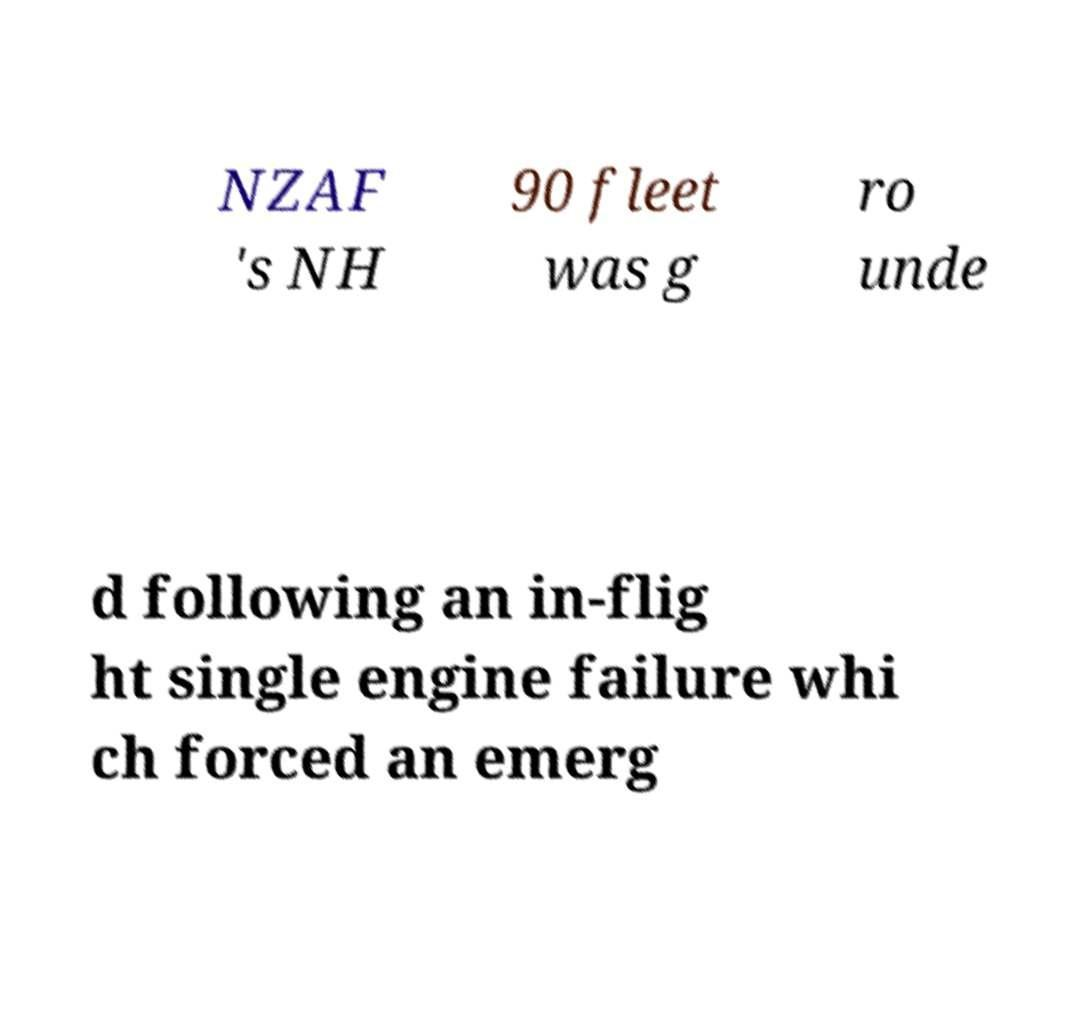Can you read and provide the text displayed in the image?This photo seems to have some interesting text. Can you extract and type it out for me? NZAF 's NH 90 fleet was g ro unde d following an in-flig ht single engine failure whi ch forced an emerg 